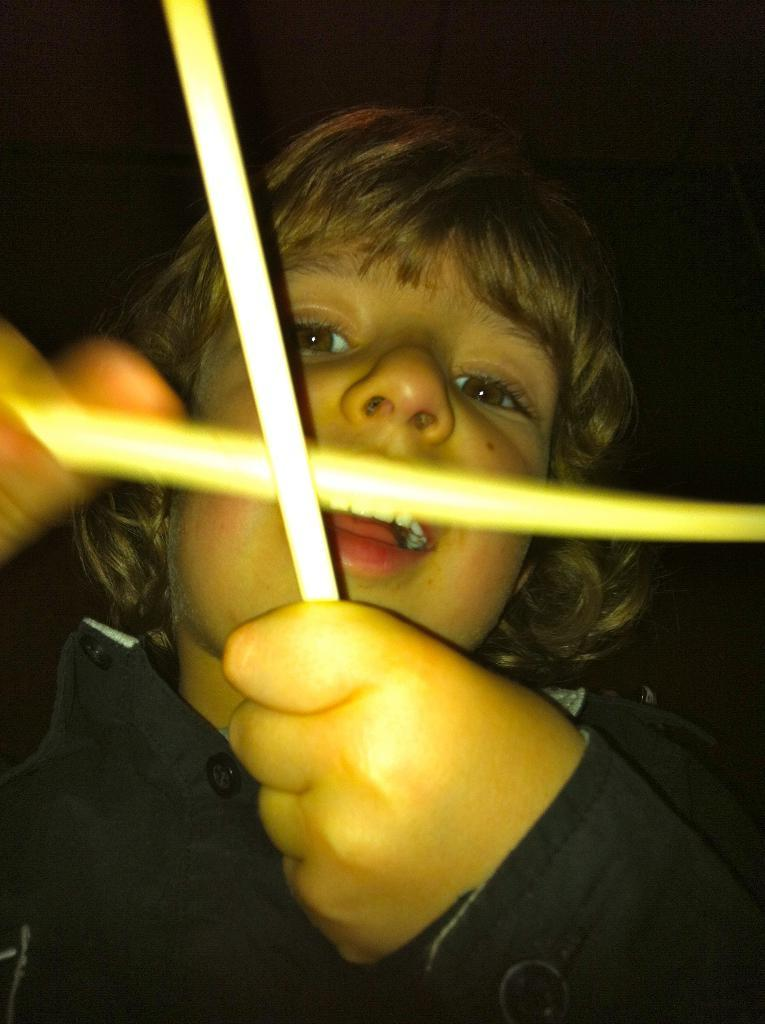What is the main subject of the image? The main subject of the image is a kid. What is the kid doing in the image? The kid is holding objects. Can you describe the background of the image? The background of the image is dark. What type of room can be seen in the background of the image? There is no room visible in the background of the image; it is dark. How many crates are present in the image? There is no crate present in the image. 